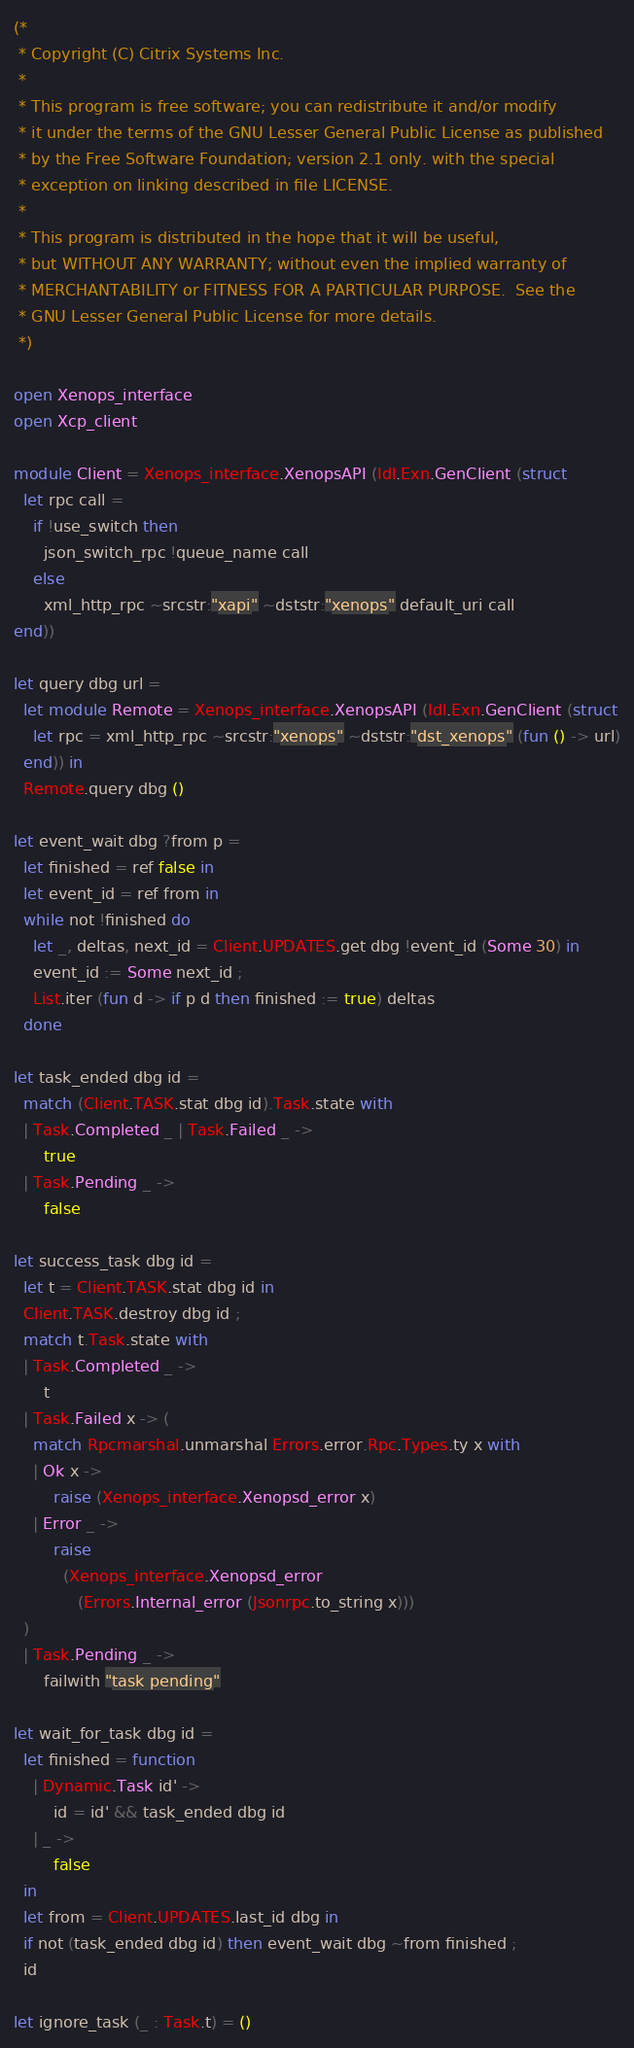<code> <loc_0><loc_0><loc_500><loc_500><_OCaml_>(*
 * Copyright (C) Citrix Systems Inc.
 *
 * This program is free software; you can redistribute it and/or modify
 * it under the terms of the GNU Lesser General Public License as published
 * by the Free Software Foundation; version 2.1 only. with the special
 * exception on linking described in file LICENSE.
 *
 * This program is distributed in the hope that it will be useful,
 * but WITHOUT ANY WARRANTY; without even the implied warranty of
 * MERCHANTABILITY or FITNESS FOR A PARTICULAR PURPOSE.  See the
 * GNU Lesser General Public License for more details.
 *)

open Xenops_interface
open Xcp_client

module Client = Xenops_interface.XenopsAPI (Idl.Exn.GenClient (struct
  let rpc call =
    if !use_switch then
      json_switch_rpc !queue_name call
    else
      xml_http_rpc ~srcstr:"xapi" ~dststr:"xenops" default_uri call
end))

let query dbg url =
  let module Remote = Xenops_interface.XenopsAPI (Idl.Exn.GenClient (struct
    let rpc = xml_http_rpc ~srcstr:"xenops" ~dststr:"dst_xenops" (fun () -> url)
  end)) in
  Remote.query dbg ()

let event_wait dbg ?from p =
  let finished = ref false in
  let event_id = ref from in
  while not !finished do
    let _, deltas, next_id = Client.UPDATES.get dbg !event_id (Some 30) in
    event_id := Some next_id ;
    List.iter (fun d -> if p d then finished := true) deltas
  done

let task_ended dbg id =
  match (Client.TASK.stat dbg id).Task.state with
  | Task.Completed _ | Task.Failed _ ->
      true
  | Task.Pending _ ->
      false

let success_task dbg id =
  let t = Client.TASK.stat dbg id in
  Client.TASK.destroy dbg id ;
  match t.Task.state with
  | Task.Completed _ ->
      t
  | Task.Failed x -> (
    match Rpcmarshal.unmarshal Errors.error.Rpc.Types.ty x with
    | Ok x ->
        raise (Xenops_interface.Xenopsd_error x)
    | Error _ ->
        raise
          (Xenops_interface.Xenopsd_error
             (Errors.Internal_error (Jsonrpc.to_string x)))
  )
  | Task.Pending _ ->
      failwith "task pending"

let wait_for_task dbg id =
  let finished = function
    | Dynamic.Task id' ->
        id = id' && task_ended dbg id
    | _ ->
        false
  in
  let from = Client.UPDATES.last_id dbg in
  if not (task_ended dbg id) then event_wait dbg ~from finished ;
  id

let ignore_task (_ : Task.t) = ()
</code> 